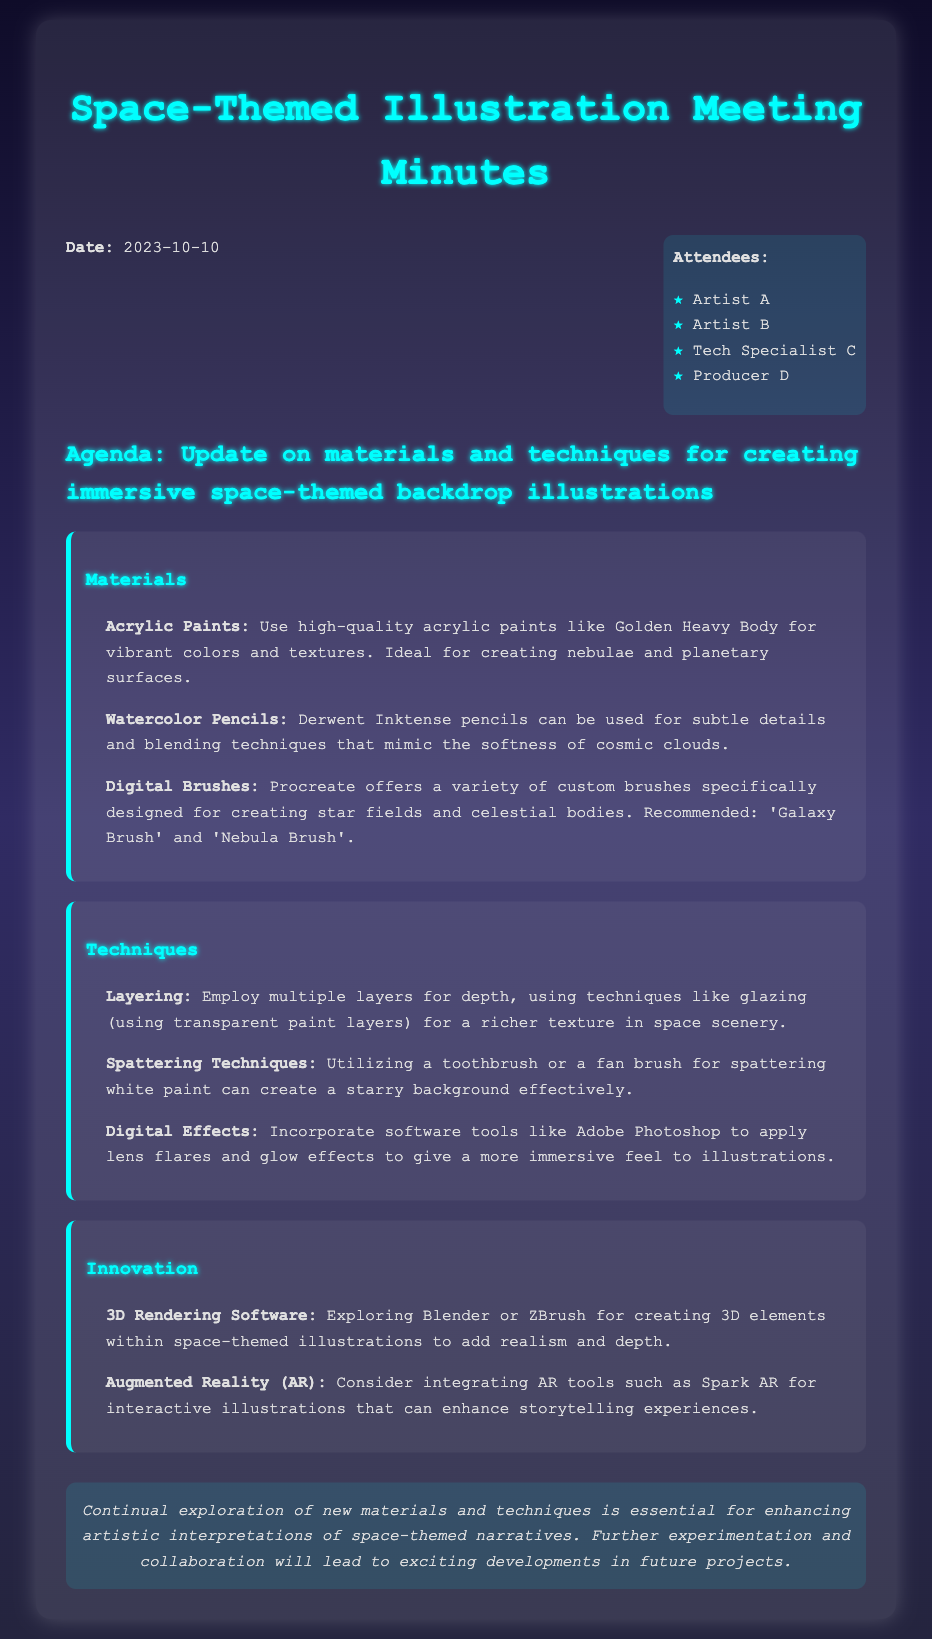what is the date of the meeting? The date is mentioned at the beginning of the document, which is October 10, 2023.
Answer: October 10, 2023 who are the attendees listed in the document? The document lists four attendees, and their names are included in an unordered list.
Answer: Artist A, Artist B, Tech Specialist C, Producer D which acrylic paint is recommended for creating nebulae? The document specifies a high-quality acrylic paint, recommended for its vibrancy in space-themed illustrations.
Answer: Golden Heavy Body what digital brushes are suggested for creating star fields? The document mentions specific brushes available in Procreate for illustrating celestial bodies.
Answer: Galaxy Brush, Nebula Brush what innovative software is mentioned for adding realism to illustrations? The document refers to software that can create 3D elements within illustrations, enhancing their depth.
Answer: Blender, ZBrush what technique is suggested for creating a starry background? The document describes a method that utilizes common tools for achieving an effect that enhances space themes.
Answer: Spattering Techniques what is one proposed application of Augmented Reality in illustrations? The document discusses a specific AR tool that can enhance storytelling experiences in the context of illustrations.
Answer: Spark AR how many topics are discussed in the meeting minutes? The document outlines three main topics under the agenda section.
Answer: Three 